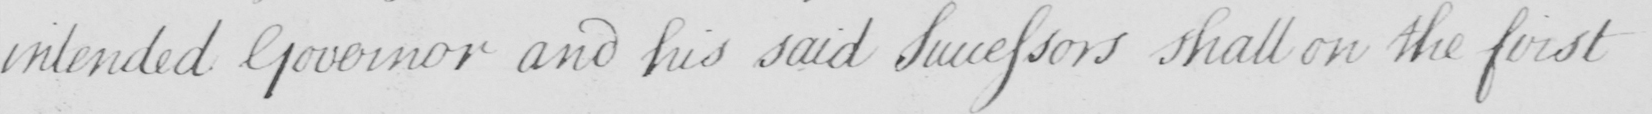Please transcribe the handwritten text in this image. intended Governor and his said Successors shall on the first 